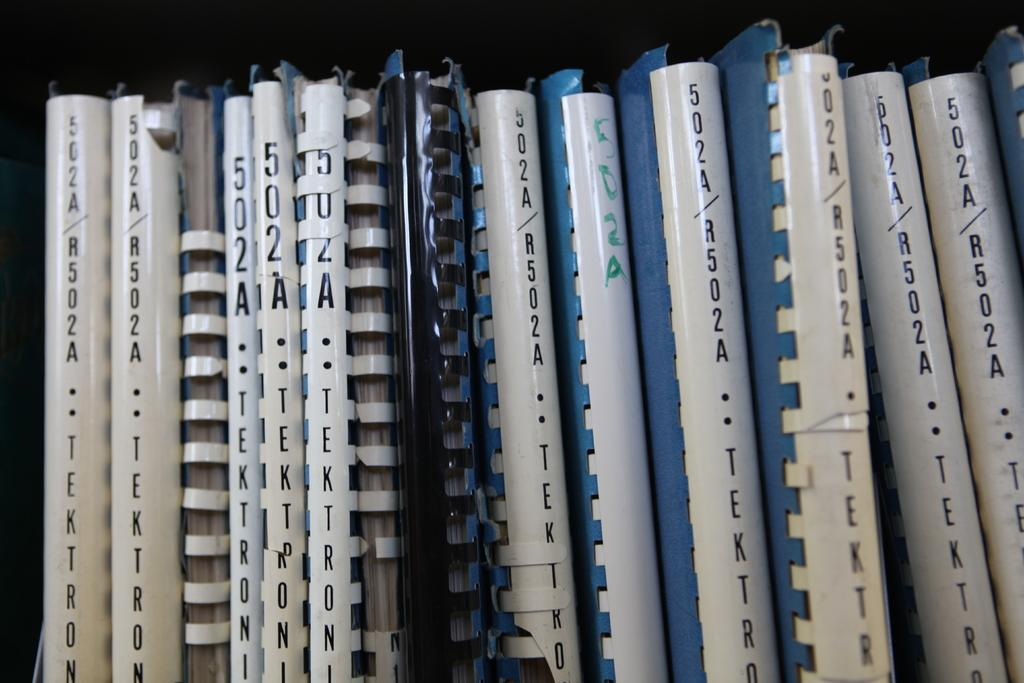What colors are present in the objects in the image? There are objects in black, white, blue, and cream colors in the image. Can you describe the background of the image? The background of the image is black. Is there any poison visible in the image? There is no mention of poison in the image, so it cannot be determined if it is present. What type of brush is being used to create the objects in the image? The image does not show any brush or painting process, so it cannot be determined what type of brush was used. 